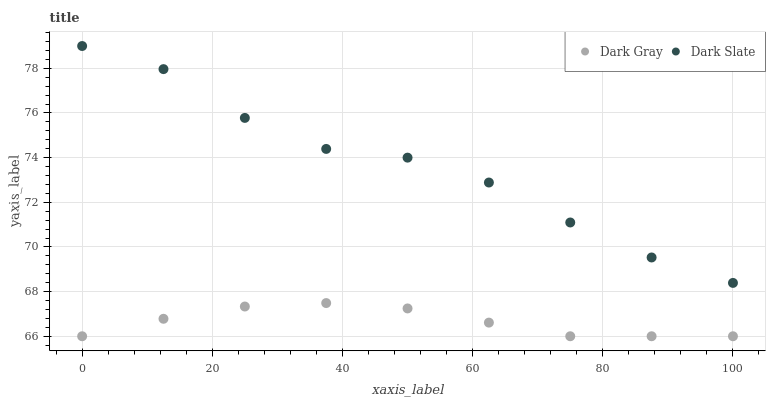Does Dark Gray have the minimum area under the curve?
Answer yes or no. Yes. Does Dark Slate have the maximum area under the curve?
Answer yes or no. Yes. Does Dark Slate have the minimum area under the curve?
Answer yes or no. No. Is Dark Gray the smoothest?
Answer yes or no. Yes. Is Dark Slate the roughest?
Answer yes or no. Yes. Is Dark Slate the smoothest?
Answer yes or no. No. Does Dark Gray have the lowest value?
Answer yes or no. Yes. Does Dark Slate have the lowest value?
Answer yes or no. No. Does Dark Slate have the highest value?
Answer yes or no. Yes. Is Dark Gray less than Dark Slate?
Answer yes or no. Yes. Is Dark Slate greater than Dark Gray?
Answer yes or no. Yes. Does Dark Gray intersect Dark Slate?
Answer yes or no. No. 